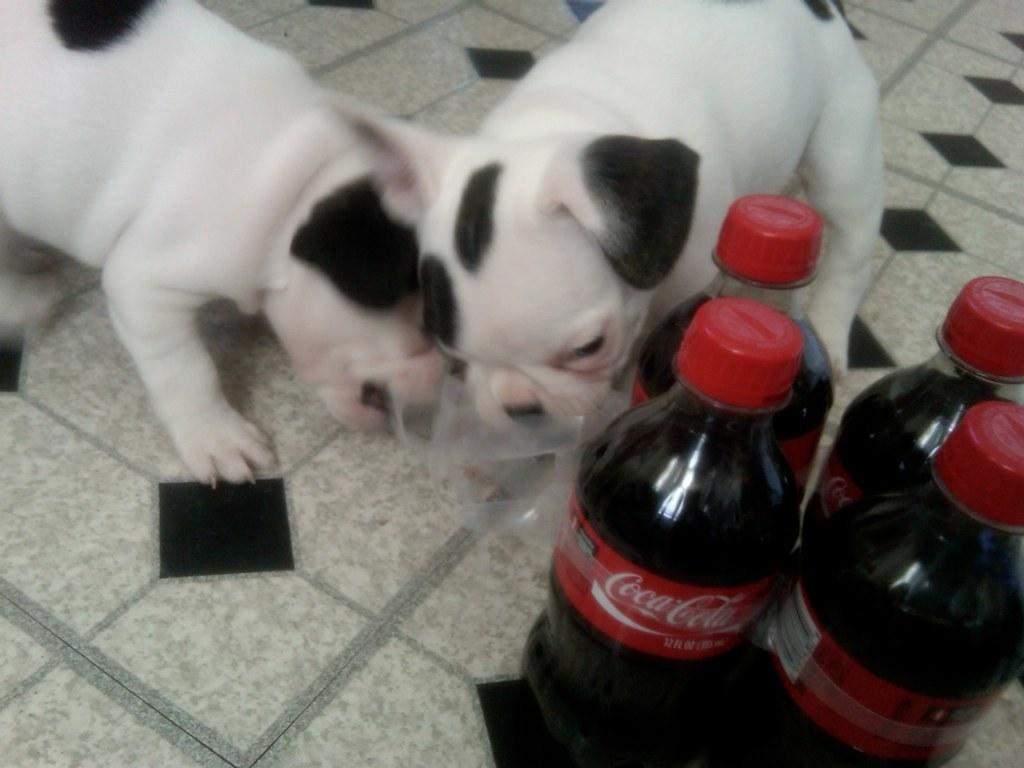How many dogs are present in the image? There are two dogs in the image. What else can be seen on the right side of the image? There are cool drink bottles on the right side of the image. Is there a beggar asking for money in the image? No, there is no beggar present in the image. Can you tell me how the bottle moves in the image? The bottle does not move in the image; it is stationary. 